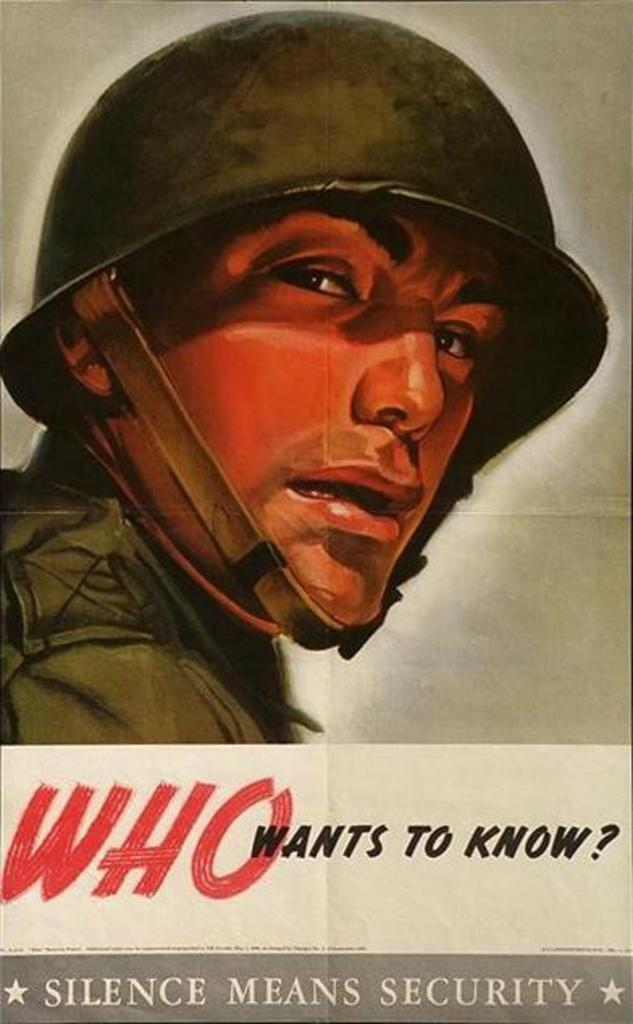<image>
Relay a brief, clear account of the picture shown. A poster of a military person that states "Who Wants to Know", Silence Means Security. 